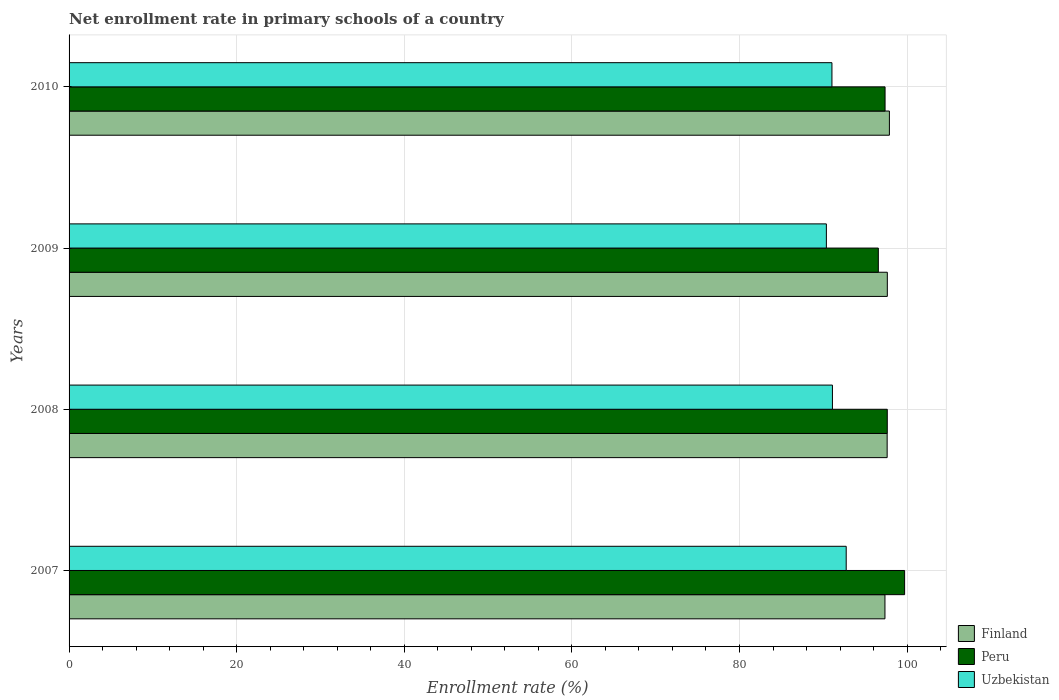How many groups of bars are there?
Your response must be concise. 4. Are the number of bars per tick equal to the number of legend labels?
Keep it short and to the point. Yes. Are the number of bars on each tick of the Y-axis equal?
Give a very brief answer. Yes. How many bars are there on the 2nd tick from the top?
Provide a succinct answer. 3. How many bars are there on the 1st tick from the bottom?
Offer a terse response. 3. In how many cases, is the number of bars for a given year not equal to the number of legend labels?
Your response must be concise. 0. What is the enrollment rate in primary schools in Uzbekistan in 2009?
Provide a short and direct response. 90.37. Across all years, what is the maximum enrollment rate in primary schools in Finland?
Provide a succinct answer. 97.89. Across all years, what is the minimum enrollment rate in primary schools in Finland?
Your answer should be compact. 97.36. In which year was the enrollment rate in primary schools in Finland maximum?
Ensure brevity in your answer.  2010. What is the total enrollment rate in primary schools in Finland in the graph?
Make the answer very short. 390.52. What is the difference between the enrollment rate in primary schools in Peru in 2009 and that in 2010?
Your answer should be very brief. -0.8. What is the difference between the enrollment rate in primary schools in Peru in 2010 and the enrollment rate in primary schools in Uzbekistan in 2007?
Offer a terse response. 4.64. What is the average enrollment rate in primary schools in Peru per year?
Ensure brevity in your answer.  97.82. In the year 2008, what is the difference between the enrollment rate in primary schools in Finland and enrollment rate in primary schools in Uzbekistan?
Provide a succinct answer. 6.53. In how many years, is the enrollment rate in primary schools in Peru greater than 48 %?
Offer a terse response. 4. What is the ratio of the enrollment rate in primary schools in Uzbekistan in 2007 to that in 2010?
Your answer should be very brief. 1.02. Is the enrollment rate in primary schools in Peru in 2008 less than that in 2010?
Your answer should be very brief. No. What is the difference between the highest and the second highest enrollment rate in primary schools in Finland?
Offer a very short reply. 0.25. What is the difference between the highest and the lowest enrollment rate in primary schools in Peru?
Your answer should be compact. 3.14. What does the 1st bar from the top in 2008 represents?
Make the answer very short. Uzbekistan. What does the 3rd bar from the bottom in 2010 represents?
Your answer should be compact. Uzbekistan. How many bars are there?
Give a very brief answer. 12. Are all the bars in the graph horizontal?
Provide a short and direct response. Yes. What is the difference between two consecutive major ticks on the X-axis?
Your answer should be compact. 20. Are the values on the major ticks of X-axis written in scientific E-notation?
Give a very brief answer. No. Does the graph contain grids?
Your answer should be compact. Yes. How many legend labels are there?
Keep it short and to the point. 3. What is the title of the graph?
Your answer should be very brief. Net enrollment rate in primary schools of a country. What is the label or title of the X-axis?
Your answer should be compact. Enrollment rate (%). What is the Enrollment rate (%) in Finland in 2007?
Give a very brief answer. 97.36. What is the Enrollment rate (%) in Peru in 2007?
Ensure brevity in your answer.  99.71. What is the Enrollment rate (%) in Uzbekistan in 2007?
Ensure brevity in your answer.  92.74. What is the Enrollment rate (%) in Finland in 2008?
Your answer should be very brief. 97.62. What is the Enrollment rate (%) in Peru in 2008?
Give a very brief answer. 97.64. What is the Enrollment rate (%) of Uzbekistan in 2008?
Make the answer very short. 91.09. What is the Enrollment rate (%) of Finland in 2009?
Offer a terse response. 97.64. What is the Enrollment rate (%) in Peru in 2009?
Provide a succinct answer. 96.57. What is the Enrollment rate (%) in Uzbekistan in 2009?
Provide a short and direct response. 90.37. What is the Enrollment rate (%) of Finland in 2010?
Provide a succinct answer. 97.89. What is the Enrollment rate (%) of Peru in 2010?
Offer a very short reply. 97.37. What is the Enrollment rate (%) of Uzbekistan in 2010?
Keep it short and to the point. 91.03. Across all years, what is the maximum Enrollment rate (%) of Finland?
Your answer should be very brief. 97.89. Across all years, what is the maximum Enrollment rate (%) in Peru?
Give a very brief answer. 99.71. Across all years, what is the maximum Enrollment rate (%) in Uzbekistan?
Ensure brevity in your answer.  92.74. Across all years, what is the minimum Enrollment rate (%) of Finland?
Make the answer very short. 97.36. Across all years, what is the minimum Enrollment rate (%) in Peru?
Your response must be concise. 96.57. Across all years, what is the minimum Enrollment rate (%) of Uzbekistan?
Your response must be concise. 90.37. What is the total Enrollment rate (%) of Finland in the graph?
Keep it short and to the point. 390.52. What is the total Enrollment rate (%) of Peru in the graph?
Make the answer very short. 391.29. What is the total Enrollment rate (%) of Uzbekistan in the graph?
Make the answer very short. 365.23. What is the difference between the Enrollment rate (%) in Finland in 2007 and that in 2008?
Offer a very short reply. -0.26. What is the difference between the Enrollment rate (%) of Peru in 2007 and that in 2008?
Provide a succinct answer. 2.07. What is the difference between the Enrollment rate (%) of Uzbekistan in 2007 and that in 2008?
Provide a short and direct response. 1.64. What is the difference between the Enrollment rate (%) in Finland in 2007 and that in 2009?
Provide a succinct answer. -0.28. What is the difference between the Enrollment rate (%) in Peru in 2007 and that in 2009?
Keep it short and to the point. 3.14. What is the difference between the Enrollment rate (%) in Uzbekistan in 2007 and that in 2009?
Make the answer very short. 2.37. What is the difference between the Enrollment rate (%) in Finland in 2007 and that in 2010?
Make the answer very short. -0.53. What is the difference between the Enrollment rate (%) of Peru in 2007 and that in 2010?
Keep it short and to the point. 2.33. What is the difference between the Enrollment rate (%) in Uzbekistan in 2007 and that in 2010?
Give a very brief answer. 1.7. What is the difference between the Enrollment rate (%) in Finland in 2008 and that in 2009?
Your response must be concise. -0.02. What is the difference between the Enrollment rate (%) in Peru in 2008 and that in 2009?
Provide a short and direct response. 1.07. What is the difference between the Enrollment rate (%) of Uzbekistan in 2008 and that in 2009?
Provide a succinct answer. 0.72. What is the difference between the Enrollment rate (%) in Finland in 2008 and that in 2010?
Your response must be concise. -0.27. What is the difference between the Enrollment rate (%) in Peru in 2008 and that in 2010?
Give a very brief answer. 0.27. What is the difference between the Enrollment rate (%) of Uzbekistan in 2008 and that in 2010?
Ensure brevity in your answer.  0.06. What is the difference between the Enrollment rate (%) in Finland in 2009 and that in 2010?
Keep it short and to the point. -0.25. What is the difference between the Enrollment rate (%) in Peru in 2009 and that in 2010?
Offer a terse response. -0.8. What is the difference between the Enrollment rate (%) in Uzbekistan in 2009 and that in 2010?
Provide a succinct answer. -0.66. What is the difference between the Enrollment rate (%) of Finland in 2007 and the Enrollment rate (%) of Peru in 2008?
Offer a terse response. -0.28. What is the difference between the Enrollment rate (%) of Finland in 2007 and the Enrollment rate (%) of Uzbekistan in 2008?
Make the answer very short. 6.27. What is the difference between the Enrollment rate (%) of Peru in 2007 and the Enrollment rate (%) of Uzbekistan in 2008?
Make the answer very short. 8.61. What is the difference between the Enrollment rate (%) of Finland in 2007 and the Enrollment rate (%) of Peru in 2009?
Your answer should be compact. 0.79. What is the difference between the Enrollment rate (%) of Finland in 2007 and the Enrollment rate (%) of Uzbekistan in 2009?
Keep it short and to the point. 6.99. What is the difference between the Enrollment rate (%) in Peru in 2007 and the Enrollment rate (%) in Uzbekistan in 2009?
Provide a short and direct response. 9.33. What is the difference between the Enrollment rate (%) of Finland in 2007 and the Enrollment rate (%) of Peru in 2010?
Provide a short and direct response. -0.01. What is the difference between the Enrollment rate (%) in Finland in 2007 and the Enrollment rate (%) in Uzbekistan in 2010?
Provide a succinct answer. 6.33. What is the difference between the Enrollment rate (%) in Peru in 2007 and the Enrollment rate (%) in Uzbekistan in 2010?
Keep it short and to the point. 8.67. What is the difference between the Enrollment rate (%) in Finland in 2008 and the Enrollment rate (%) in Peru in 2009?
Offer a very short reply. 1.05. What is the difference between the Enrollment rate (%) in Finland in 2008 and the Enrollment rate (%) in Uzbekistan in 2009?
Provide a succinct answer. 7.25. What is the difference between the Enrollment rate (%) in Peru in 2008 and the Enrollment rate (%) in Uzbekistan in 2009?
Provide a short and direct response. 7.27. What is the difference between the Enrollment rate (%) in Finland in 2008 and the Enrollment rate (%) in Peru in 2010?
Offer a terse response. 0.25. What is the difference between the Enrollment rate (%) of Finland in 2008 and the Enrollment rate (%) of Uzbekistan in 2010?
Your response must be concise. 6.59. What is the difference between the Enrollment rate (%) in Peru in 2008 and the Enrollment rate (%) in Uzbekistan in 2010?
Give a very brief answer. 6.61. What is the difference between the Enrollment rate (%) of Finland in 2009 and the Enrollment rate (%) of Peru in 2010?
Ensure brevity in your answer.  0.27. What is the difference between the Enrollment rate (%) in Finland in 2009 and the Enrollment rate (%) in Uzbekistan in 2010?
Keep it short and to the point. 6.61. What is the difference between the Enrollment rate (%) of Peru in 2009 and the Enrollment rate (%) of Uzbekistan in 2010?
Offer a very short reply. 5.54. What is the average Enrollment rate (%) in Finland per year?
Keep it short and to the point. 97.63. What is the average Enrollment rate (%) in Peru per year?
Make the answer very short. 97.82. What is the average Enrollment rate (%) of Uzbekistan per year?
Your answer should be compact. 91.31. In the year 2007, what is the difference between the Enrollment rate (%) in Finland and Enrollment rate (%) in Peru?
Provide a short and direct response. -2.35. In the year 2007, what is the difference between the Enrollment rate (%) of Finland and Enrollment rate (%) of Uzbekistan?
Offer a very short reply. 4.62. In the year 2007, what is the difference between the Enrollment rate (%) in Peru and Enrollment rate (%) in Uzbekistan?
Give a very brief answer. 6.97. In the year 2008, what is the difference between the Enrollment rate (%) in Finland and Enrollment rate (%) in Peru?
Offer a terse response. -0.01. In the year 2008, what is the difference between the Enrollment rate (%) of Finland and Enrollment rate (%) of Uzbekistan?
Keep it short and to the point. 6.53. In the year 2008, what is the difference between the Enrollment rate (%) of Peru and Enrollment rate (%) of Uzbekistan?
Your answer should be compact. 6.55. In the year 2009, what is the difference between the Enrollment rate (%) of Finland and Enrollment rate (%) of Peru?
Your answer should be compact. 1.07. In the year 2009, what is the difference between the Enrollment rate (%) of Finland and Enrollment rate (%) of Uzbekistan?
Offer a very short reply. 7.27. In the year 2009, what is the difference between the Enrollment rate (%) of Peru and Enrollment rate (%) of Uzbekistan?
Ensure brevity in your answer.  6.2. In the year 2010, what is the difference between the Enrollment rate (%) in Finland and Enrollment rate (%) in Peru?
Provide a succinct answer. 0.52. In the year 2010, what is the difference between the Enrollment rate (%) in Finland and Enrollment rate (%) in Uzbekistan?
Provide a short and direct response. 6.86. In the year 2010, what is the difference between the Enrollment rate (%) in Peru and Enrollment rate (%) in Uzbekistan?
Keep it short and to the point. 6.34. What is the ratio of the Enrollment rate (%) in Peru in 2007 to that in 2008?
Give a very brief answer. 1.02. What is the ratio of the Enrollment rate (%) of Uzbekistan in 2007 to that in 2008?
Your answer should be very brief. 1.02. What is the ratio of the Enrollment rate (%) in Finland in 2007 to that in 2009?
Make the answer very short. 1. What is the ratio of the Enrollment rate (%) in Peru in 2007 to that in 2009?
Your response must be concise. 1.03. What is the ratio of the Enrollment rate (%) in Uzbekistan in 2007 to that in 2009?
Keep it short and to the point. 1.03. What is the ratio of the Enrollment rate (%) of Peru in 2007 to that in 2010?
Keep it short and to the point. 1.02. What is the ratio of the Enrollment rate (%) in Uzbekistan in 2007 to that in 2010?
Offer a terse response. 1.02. What is the ratio of the Enrollment rate (%) in Peru in 2008 to that in 2009?
Make the answer very short. 1.01. What is the ratio of the Enrollment rate (%) of Uzbekistan in 2008 to that in 2009?
Ensure brevity in your answer.  1.01. What is the ratio of the Enrollment rate (%) in Peru in 2008 to that in 2010?
Ensure brevity in your answer.  1. What is the ratio of the Enrollment rate (%) of Uzbekistan in 2008 to that in 2010?
Your response must be concise. 1. What is the ratio of the Enrollment rate (%) of Finland in 2009 to that in 2010?
Your answer should be compact. 1. What is the ratio of the Enrollment rate (%) in Peru in 2009 to that in 2010?
Give a very brief answer. 0.99. What is the difference between the highest and the second highest Enrollment rate (%) in Finland?
Offer a terse response. 0.25. What is the difference between the highest and the second highest Enrollment rate (%) in Peru?
Offer a very short reply. 2.07. What is the difference between the highest and the second highest Enrollment rate (%) in Uzbekistan?
Offer a terse response. 1.64. What is the difference between the highest and the lowest Enrollment rate (%) of Finland?
Ensure brevity in your answer.  0.53. What is the difference between the highest and the lowest Enrollment rate (%) of Peru?
Offer a very short reply. 3.14. What is the difference between the highest and the lowest Enrollment rate (%) of Uzbekistan?
Offer a terse response. 2.37. 